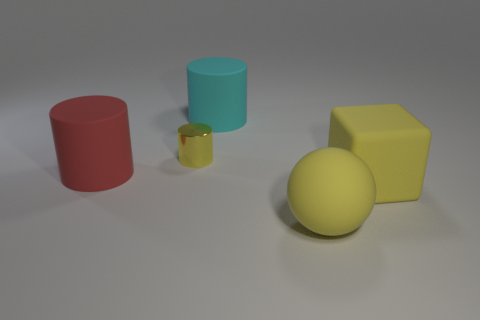Subtract all large rubber cylinders. How many cylinders are left? 1 Add 5 red matte cylinders. How many objects exist? 10 Subtract all brown cylinders. Subtract all brown spheres. How many cylinders are left? 3 Subtract all blocks. How many objects are left? 4 Add 4 blocks. How many blocks exist? 5 Subtract 1 yellow balls. How many objects are left? 4 Subtract all tiny shiny cylinders. Subtract all large cyan cylinders. How many objects are left? 3 Add 3 spheres. How many spheres are left? 4 